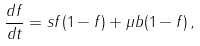<formula> <loc_0><loc_0><loc_500><loc_500>\frac { d f } { d t } = s f ( 1 - f ) + \mu b ( 1 - f ) \, ,</formula> 